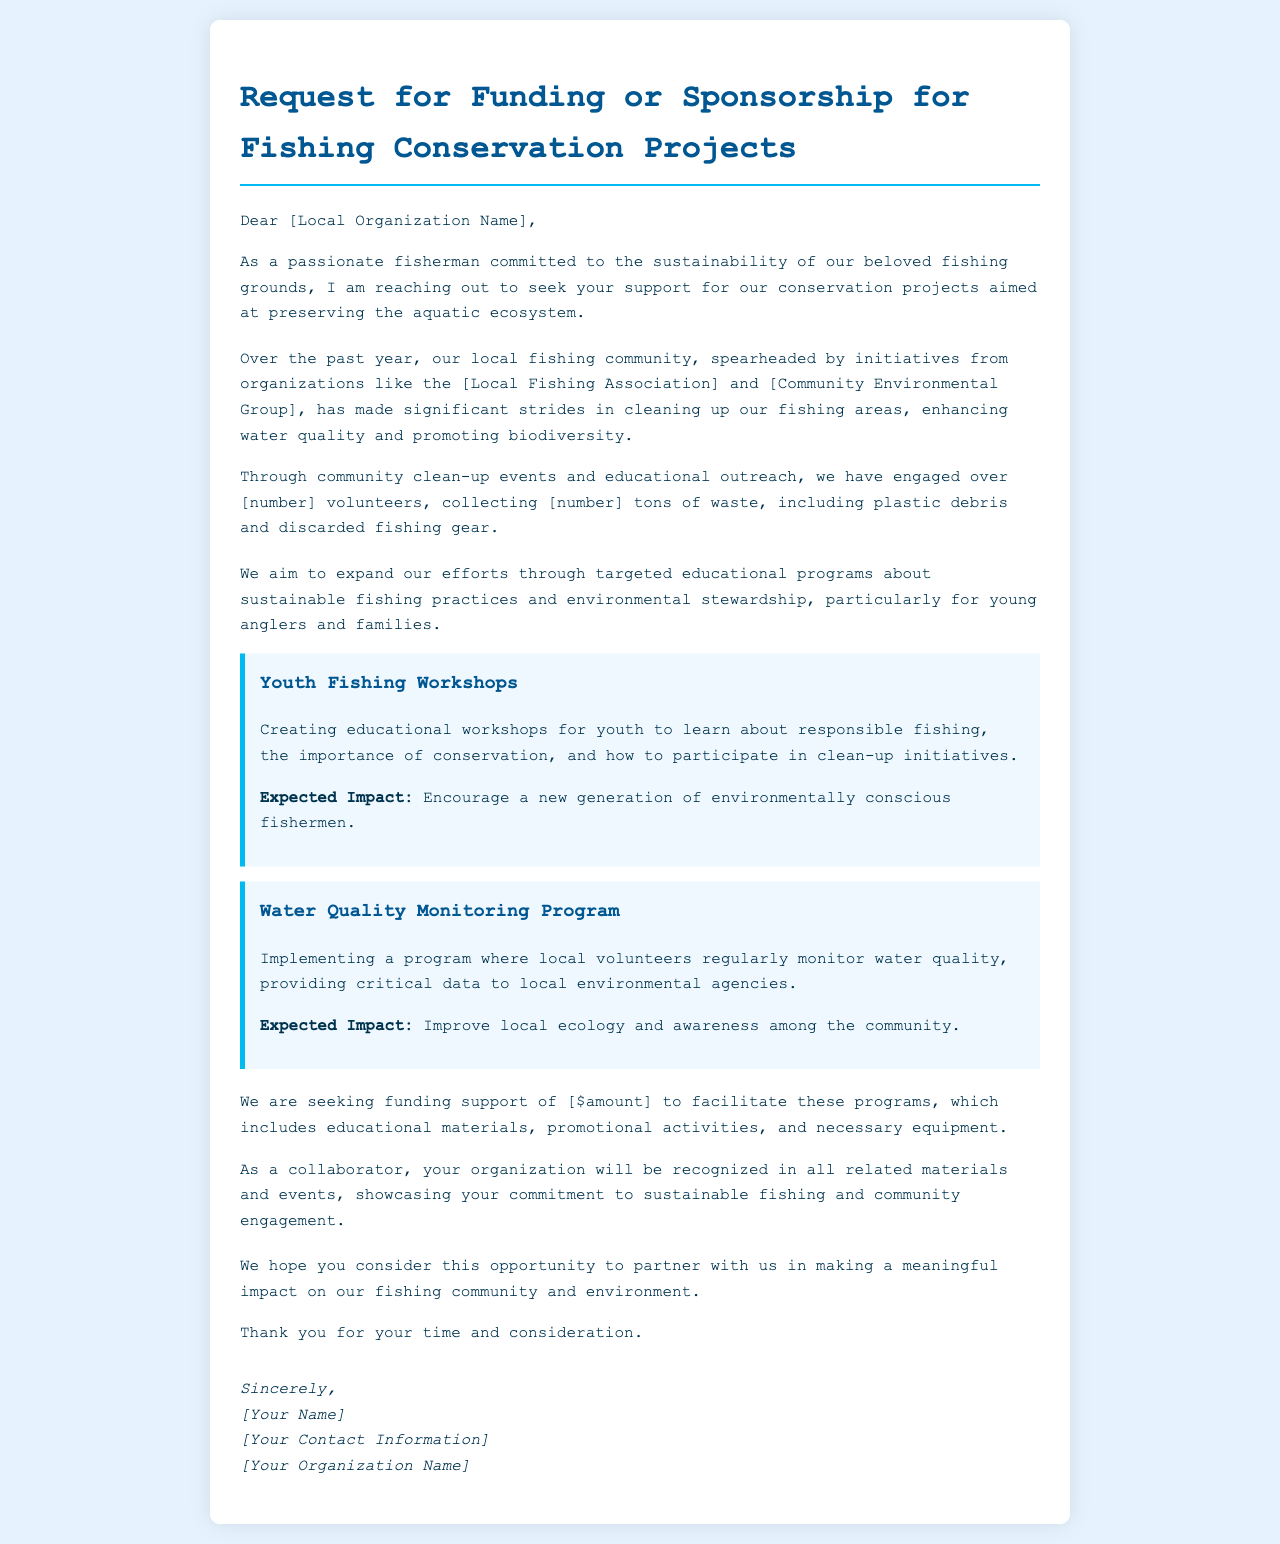what is the title of the document? The title of the document specifies the main purpose it serves, which is a Request for Funding or Sponsorship.
Answer: Request for Funding or Sponsorship for Fishing Conservation Projects who is the letter addressed to? The letter is directed towards a local organization, specifically mentioned in the salutation.
Answer: [Local Organization Name] how many volunteers engaged in the clean-up events? The document mentions ongoing efforts and the number of volunteers involved in these initiatives.
Answer: [number] what is the expected impact of the Youth Fishing Workshops? The document describes the intended outcomes of the workshop initiative for the community and future fishermen.
Answer: Encourage a new generation of environmentally conscious fishermen how much funding support is being sought? The letter explicitly states the amount of financial support requested for the various programs detailed.
Answer: [$amount] which initiative focuses on water quality? The document lists projects aimed at improving environmental conditions, specifically mentioning one related to monitoring water.
Answer: Water Quality Monitoring Program 